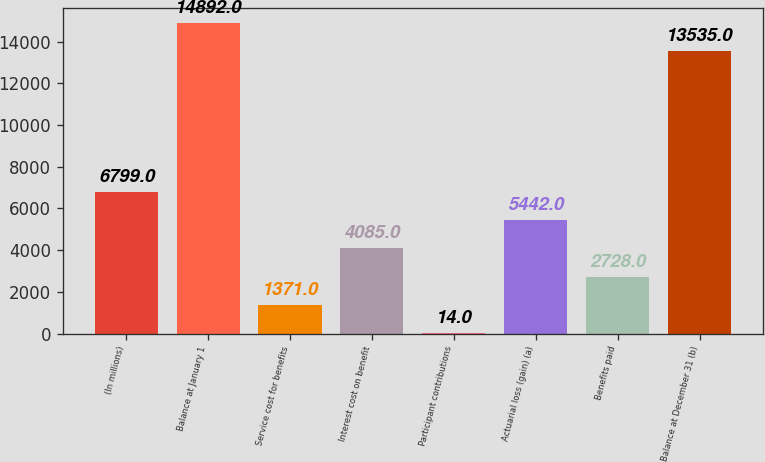Convert chart. <chart><loc_0><loc_0><loc_500><loc_500><bar_chart><fcel>(In millions)<fcel>Balance at January 1<fcel>Service cost for benefits<fcel>Interest cost on benefit<fcel>Participant contributions<fcel>Actuarial loss (gain) (a)<fcel>Benefits paid<fcel>Balance at December 31 (b)<nl><fcel>6799<fcel>14892<fcel>1371<fcel>4085<fcel>14<fcel>5442<fcel>2728<fcel>13535<nl></chart> 